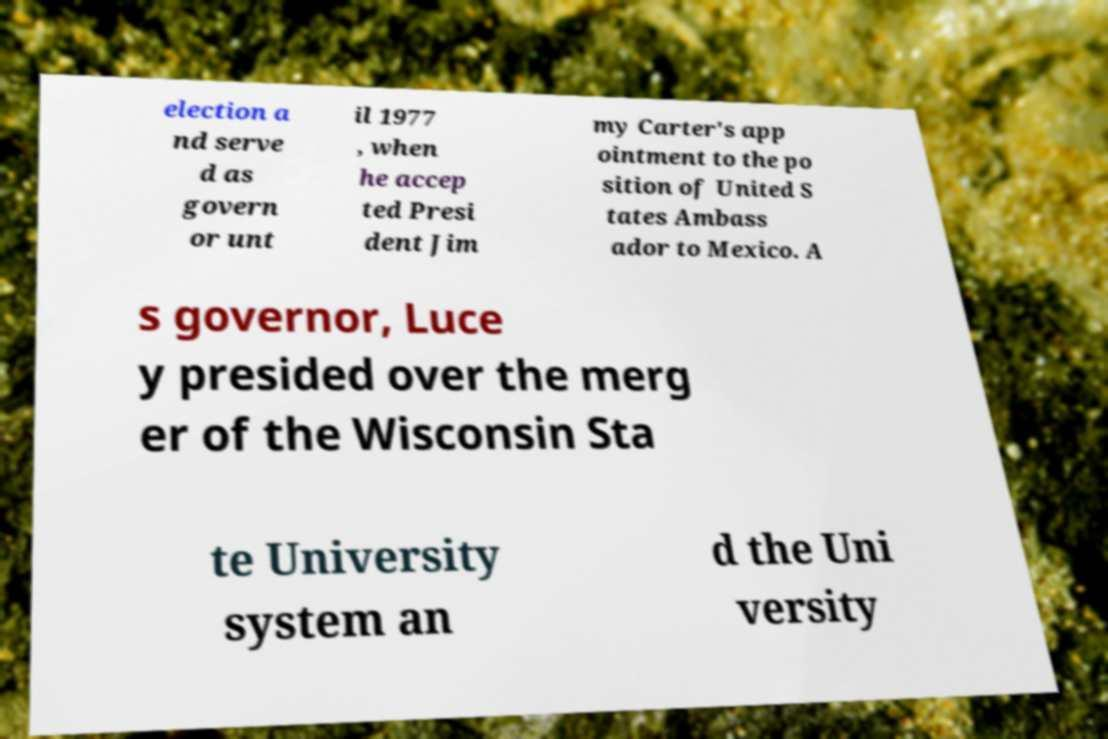I need the written content from this picture converted into text. Can you do that? election a nd serve d as govern or unt il 1977 , when he accep ted Presi dent Jim my Carter's app ointment to the po sition of United S tates Ambass ador to Mexico. A s governor, Luce y presided over the merg er of the Wisconsin Sta te University system an d the Uni versity 